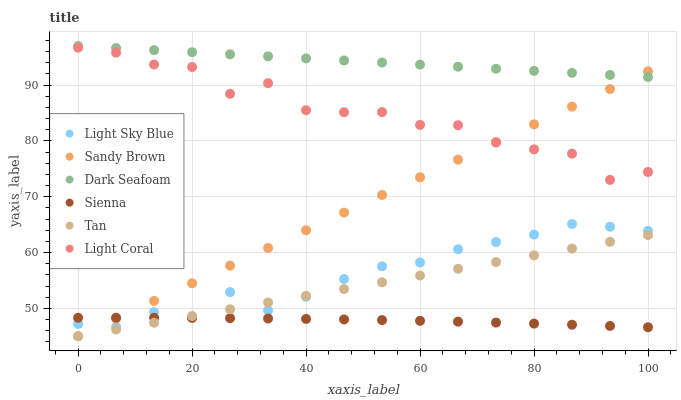Does Sienna have the minimum area under the curve?
Answer yes or no. Yes. Does Dark Seafoam have the maximum area under the curve?
Answer yes or no. Yes. Does Dark Seafoam have the minimum area under the curve?
Answer yes or no. No. Does Sienna have the maximum area under the curve?
Answer yes or no. No. Is Dark Seafoam the smoothest?
Answer yes or no. Yes. Is Light Coral the roughest?
Answer yes or no. Yes. Is Sienna the smoothest?
Answer yes or no. No. Is Sienna the roughest?
Answer yes or no. No. Does Tan have the lowest value?
Answer yes or no. Yes. Does Sienna have the lowest value?
Answer yes or no. No. Does Dark Seafoam have the highest value?
Answer yes or no. Yes. Does Sienna have the highest value?
Answer yes or no. No. Is Sienna less than Light Coral?
Answer yes or no. Yes. Is Dark Seafoam greater than Light Sky Blue?
Answer yes or no. Yes. Does Tan intersect Light Sky Blue?
Answer yes or no. Yes. Is Tan less than Light Sky Blue?
Answer yes or no. No. Is Tan greater than Light Sky Blue?
Answer yes or no. No. Does Sienna intersect Light Coral?
Answer yes or no. No. 